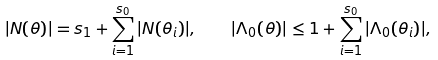Convert formula to latex. <formula><loc_0><loc_0><loc_500><loc_500>| N ( \theta ) | = s _ { 1 } + \sum _ { i = 1 } ^ { s _ { 0 } } | N ( \theta _ { i } ) | , \quad | \Lambda _ { 0 } ( \theta ) | \leq 1 + \sum _ { i = 1 } ^ { s _ { 0 } } | \Lambda _ { 0 } ( \theta _ { i } ) | ,</formula> 